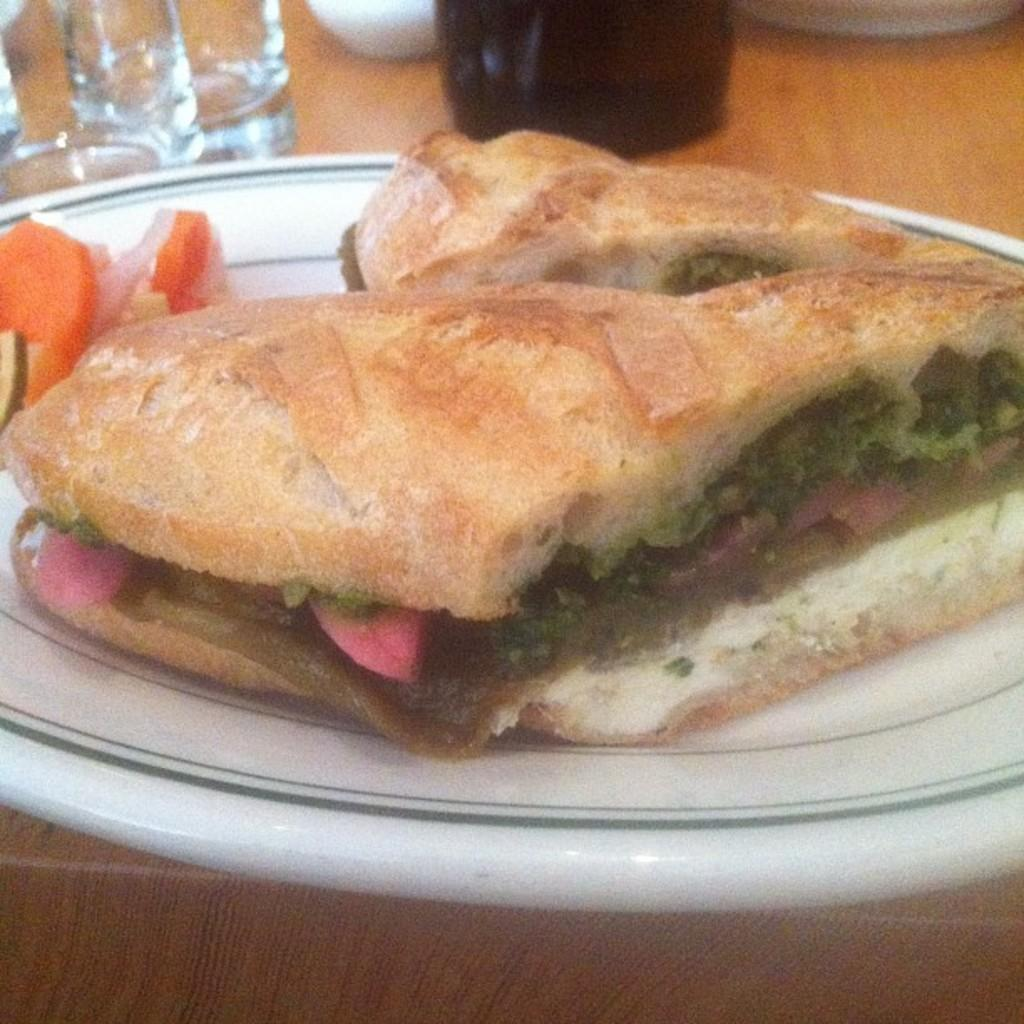What is on the plate in the image? There are food items in a plate in the image. What can be seen on the table in the image? There are glasses and other objects on the table in the image. What type of protest is happening in the image? There is no protest present in the image; it only shows food items on a plate and glasses on a table. 